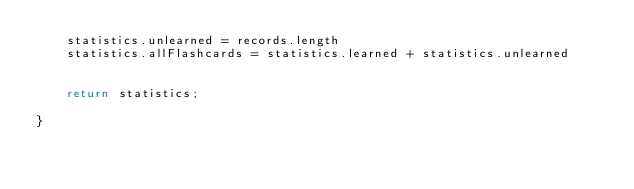Convert code to text. <code><loc_0><loc_0><loc_500><loc_500><_JavaScript_>    statistics.unlearned = records.length
    statistics.allFlashcards = statistics.learned + statistics.unlearned


    return statistics;

}

</code> 